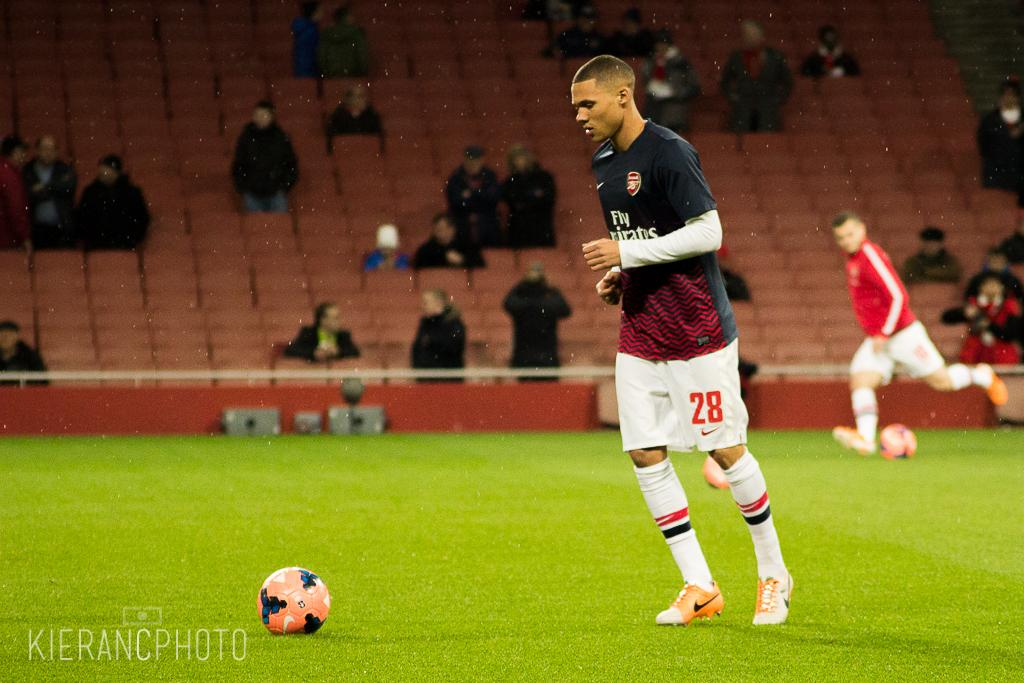What are the two persons in the image doing? The two persons in the image are playing with a ball. What is the surface they are playing on? The ground is grassy. Are there any other people in the image? Yes, there are people sitting on chairs. How many knots can be seen tied on the ball in the image? There are no knots present on the ball in the image, as it is a regular ball used for playing. 